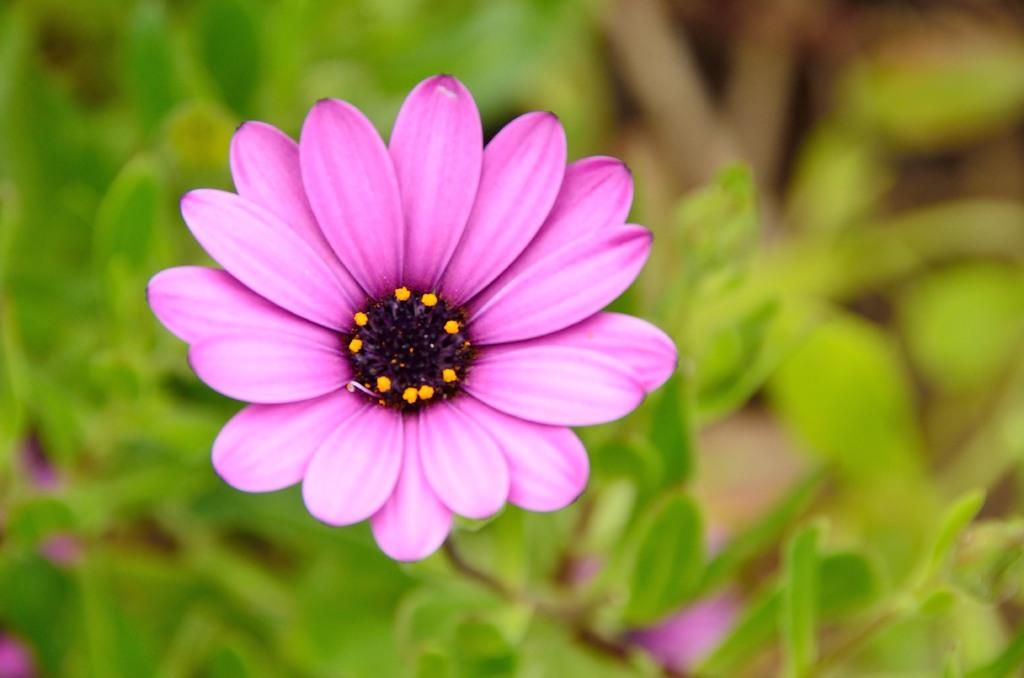What is the main subject of the image? There is a flower in the image. Can you describe the background of the image? There are plants visible behind the flower in the image. What type of transport is visible in the image? There is no transport visible in the image; it features a flower and plants in the background. What color is the icicle hanging from the flower in the image? There is no icicle present in the image, as it features a flower and plants in the background. 